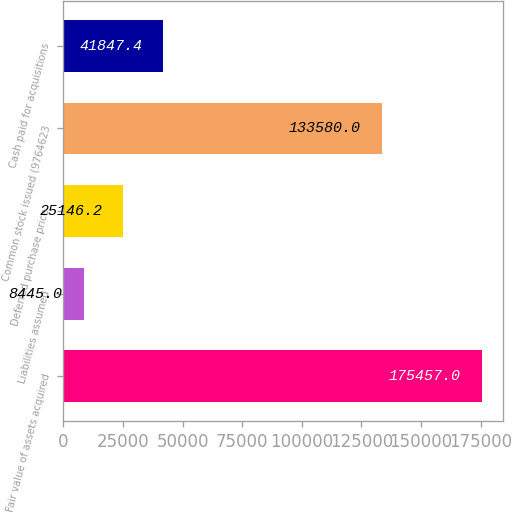Convert chart to OTSL. <chart><loc_0><loc_0><loc_500><loc_500><bar_chart><fcel>Fair value of assets acquired<fcel>Liabilities assumed<fcel>Deferred purchase price<fcel>Common stock issued (9764623<fcel>Cash paid for acquisitions<nl><fcel>175457<fcel>8445<fcel>25146.2<fcel>133580<fcel>41847.4<nl></chart> 